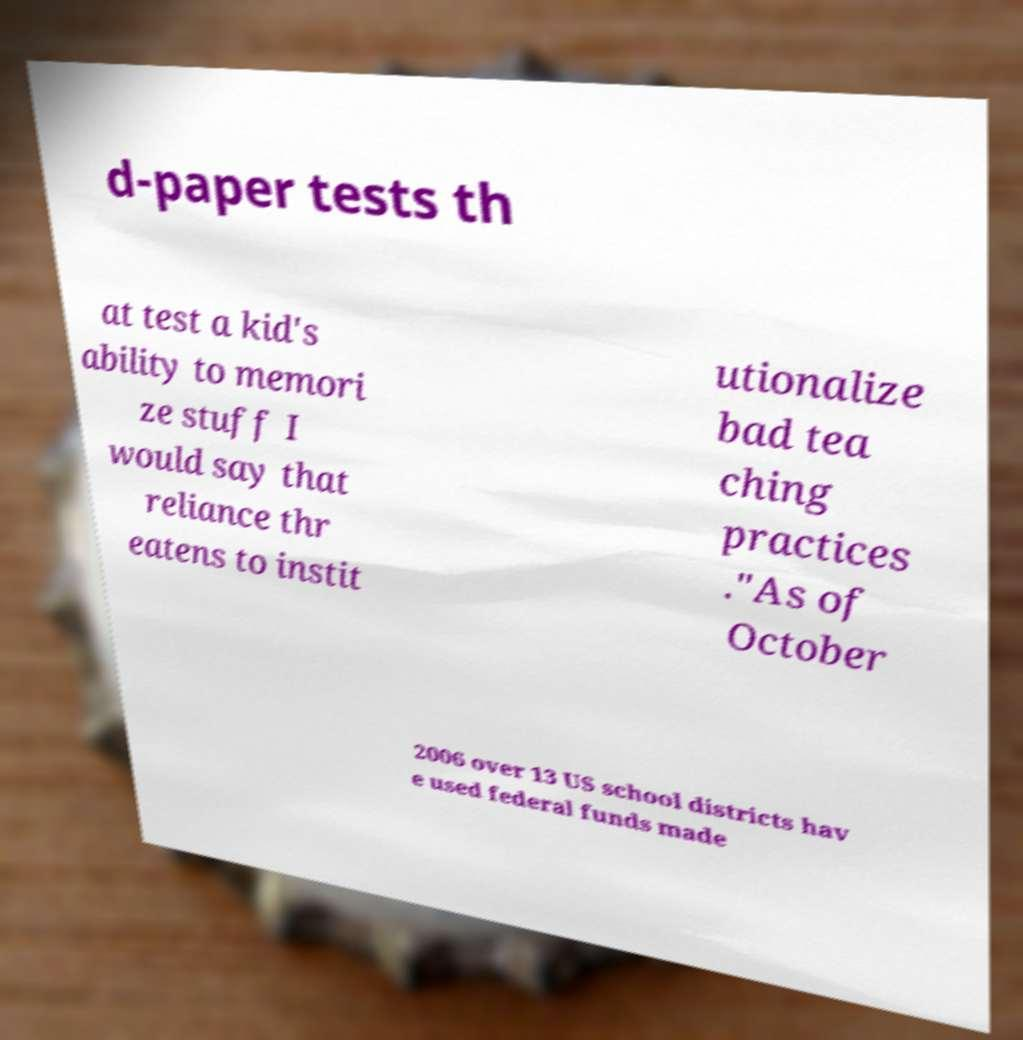There's text embedded in this image that I need extracted. Can you transcribe it verbatim? d-paper tests th at test a kid's ability to memori ze stuff I would say that reliance thr eatens to instit utionalize bad tea ching practices ."As of October 2006 over 13 US school districts hav e used federal funds made 